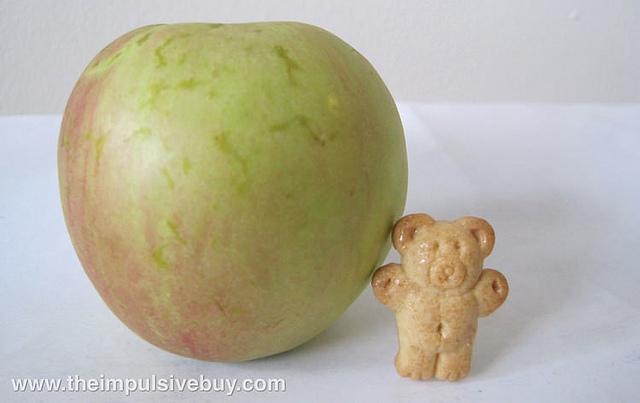Does the description: "The teddy bear is at the right side of the apple." accurately reflect the image?
Answer yes or no. Yes. Does the description: "The apple is left of the teddy bear." accurately reflect the image?
Answer yes or no. Yes. Is the statement "The teddy bear is right of the apple." accurate regarding the image?
Answer yes or no. Yes. 